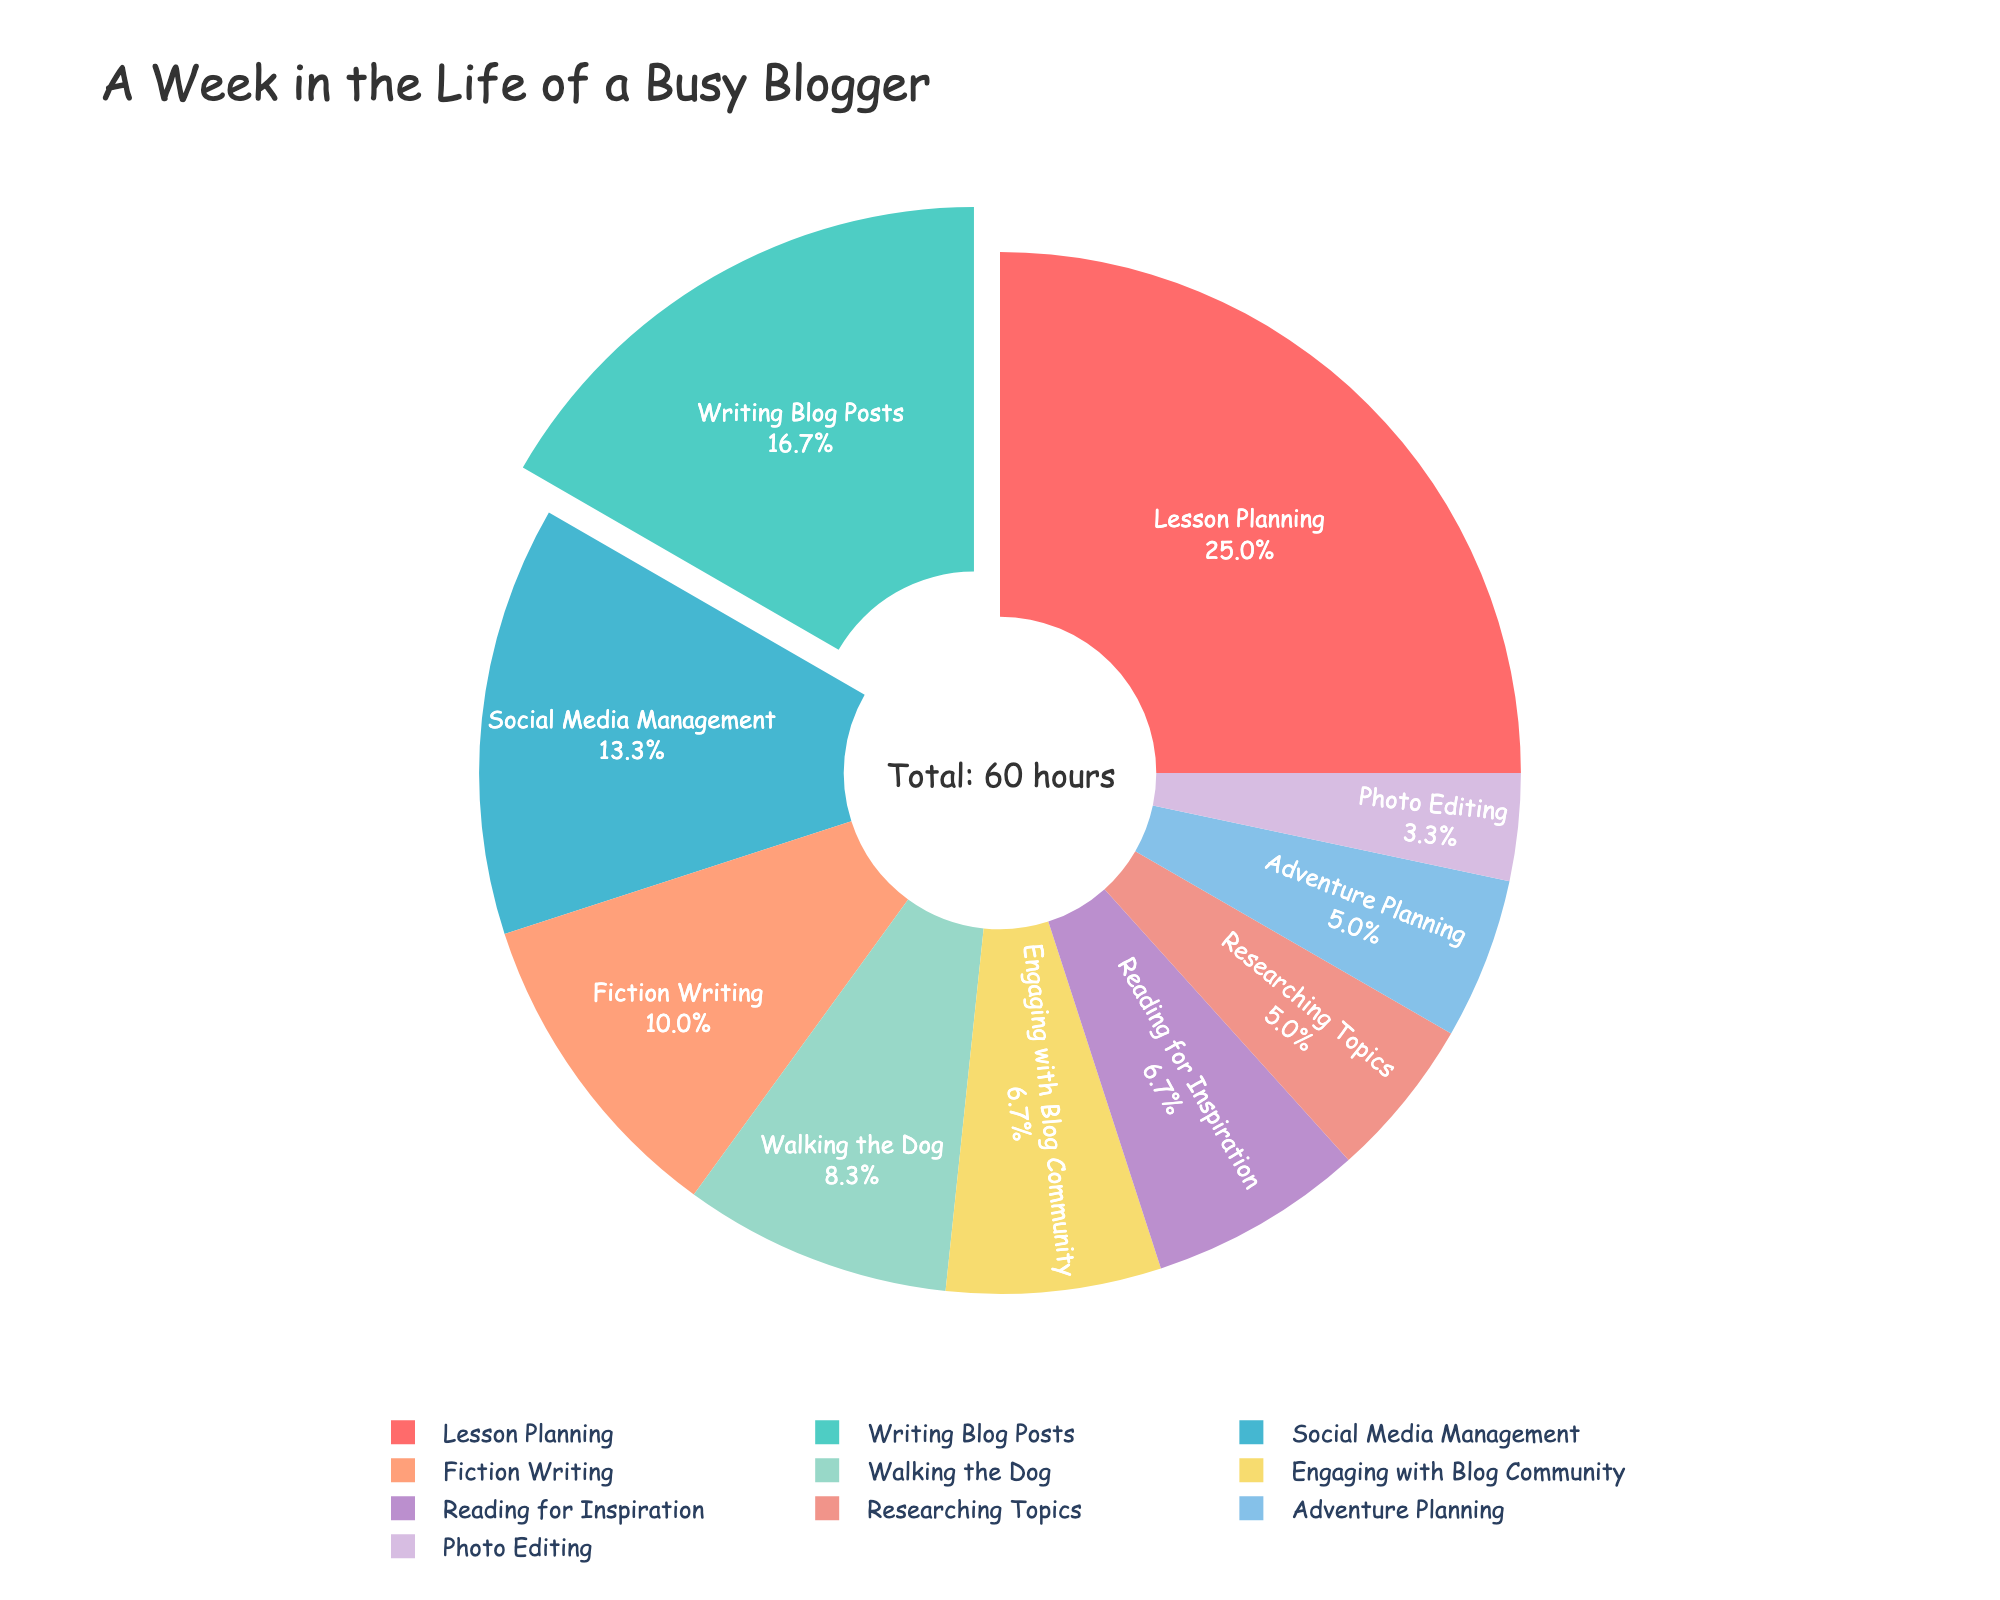What activity takes the largest percentage of the blogger's time? The pie chart shows that "Lesson Planning" takes the largest percentage of the blogger’s time. You can tell because it's the biggest slice of the pie chart and it is also pulled out slightly from the rest of the slices.
Answer: Lesson Planning Which two activities together use more hours than Social Media Management? The pie chart reveals that "Walking the Dog" (5 hours) and "Engaging with Blog Community" (4 hours) together use 9 hours, which is more than the 8 hours for Social Media Management.
Answer: Walking the Dog and Engaging with Blog Community In terms of time spent, which activity is closest to photo editing? Photo Editing takes up 2 hours per week. "Researching Topics" also takes 3 hours per week, making it the closest compared to other activities.
Answer: Researching Topics How many hours per week does the blogger spend on all writing activities combined? By summing the hours for "Writing Blog Posts" (10 hours), "Fiction Writing" (6 hours), and "Lesson Planning" (15 hours), the total is 10 + 6 + 15 = 31 hours.
Answer: 31 hours Which activity takes up exactly 5 hours of the blogger’s week? The pie chart shows that "Walking the Dog" is the activity that occupies exactly 5 hours per week.
Answer: Walking the Dog How does the time spent on Adventure Planning compare to Researching Topics? Both "Adventure Planning" and "Researching Topics" take up 3 hours each, so they are equal.
Answer: Equal Which activity takes less time: Engaging with Blog Community or Reading for Inspiration? According to the pie chart, "Engaging with Blog Community" takes 4 hours per week while "Reading for Inspiration" also takes 4 hours per week, making them equal.
Answer: Equal What is the total percentage of time spent on Walking the Dog and Fiction Writing? To determine this, add the percentages for "Walking the Dog" (5 hours) and "Fiction Writing" (6 hours). First, find the total hours: 5 + 6 = 11 hours, and then calculate the percentage: (11 hours / 60 total hours) * 100 ≈ 18.3%.
Answer: 18.3% What percentage of the week is spent on Writing Blog Posts, and how does it compare to Social Media Management? Writing Blog Posts takes 10 hours and Social Media Management takes 8 hours. Calculate their respective percentages: (10 hours / 60 total hours) * 100 ≈ 16.7% for Blog Posts and (8 hours / 60 total hours) * 100 ≈ 13.3% for Social Media. Writing Blog Posts has a higher percentage.
Answer: Writing Blog Posts: 16.7%, Social Media Management: 13.3% Are there more activities that take less than 5 hours or more than 5 hours per week? Count activities that take less than 5 hours ("Engaging with Blog Community", "Researching Topics", "Photo Editing", "Adventure Planning", "Reading for Inspiration") which are 5. Count activities that take more than 5 hours ("Writing Blog Posts", "Social Media Management", "Lesson Planning", "Fiction Writing", "Walking the Dog") which are also 5, making them equal in number.
Answer: Equal 